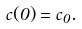<formula> <loc_0><loc_0><loc_500><loc_500>c ( 0 ) = c _ { 0 } .</formula> 